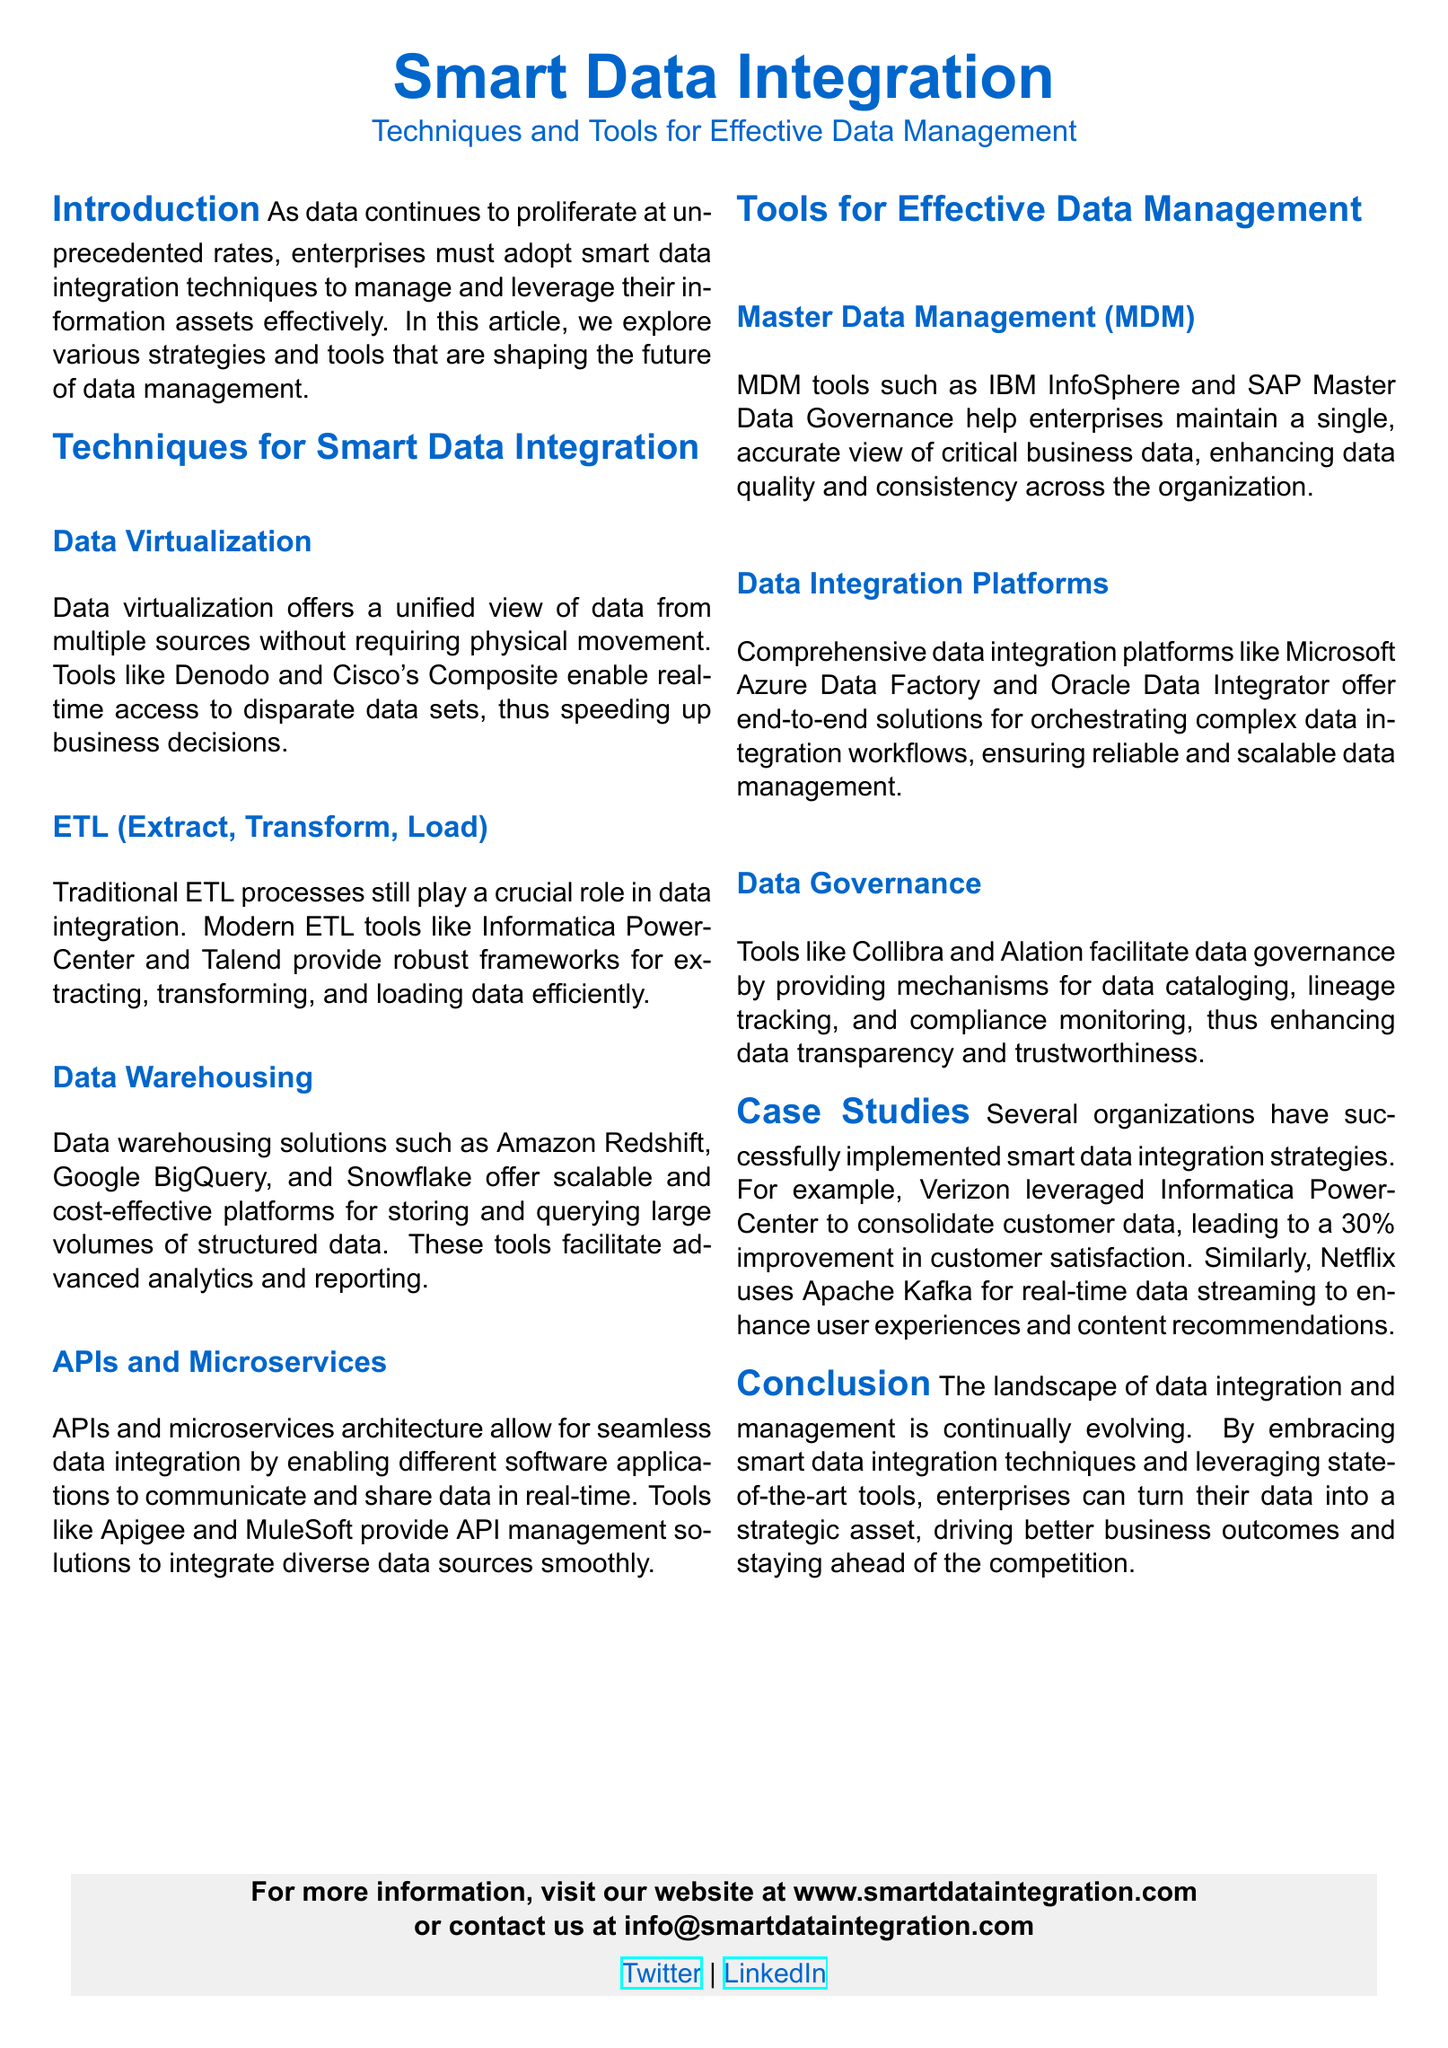What is the title of the document? The title is prominently displayed at the beginning of the document.
Answer: Smart Data Integration What technique offers a unified view of data without physical movement? This information is explained under the "Techniques for Smart Data Integration" section.
Answer: Data Virtualization Which tool is mentioned for Master Data Management? This question refers to the specific example provided in the document.
Answer: IBM InfoSphere What percentage improvement in customer satisfaction did Verizon achieve? The case study about Verizon specifically mentions this improvement.
Answer: 30% Name one service used by Netflix for real-time data streaming. The document lists this example in the case study section discussing Netflix.
Answer: Apache Kafka Which data integration platform is mentioned as Microsoft’s solution? The document lists several platforms, and this one is specifically mentioned.
Answer: Microsoft Azure Data Factory What is the main focus of the conclusion in the document? The last section summarizes the overarching theme discussed throughout the article.
Answer: Smart data integration techniques What color is used for headings in the document? This is indicated in the formatting section of the code at the beginning of the document.
Answer: My blue What is the primary purpose of data governance tools mentioned? The purpose is clarified in the section discussing data governance tools.
Answer: Data transparency and trustworthiness 